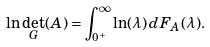Convert formula to latex. <formula><loc_0><loc_0><loc_500><loc_500>\ln \det _ { G } ( A ) = \int _ { 0 ^ { + } } ^ { \infty } \ln ( \lambda ) \, d F _ { A } ( \lambda ) .</formula> 